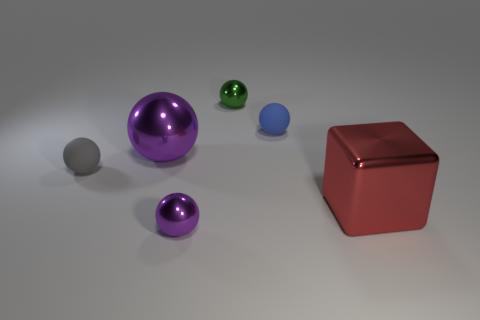Are there any big blue cylinders that have the same material as the big purple object? no 